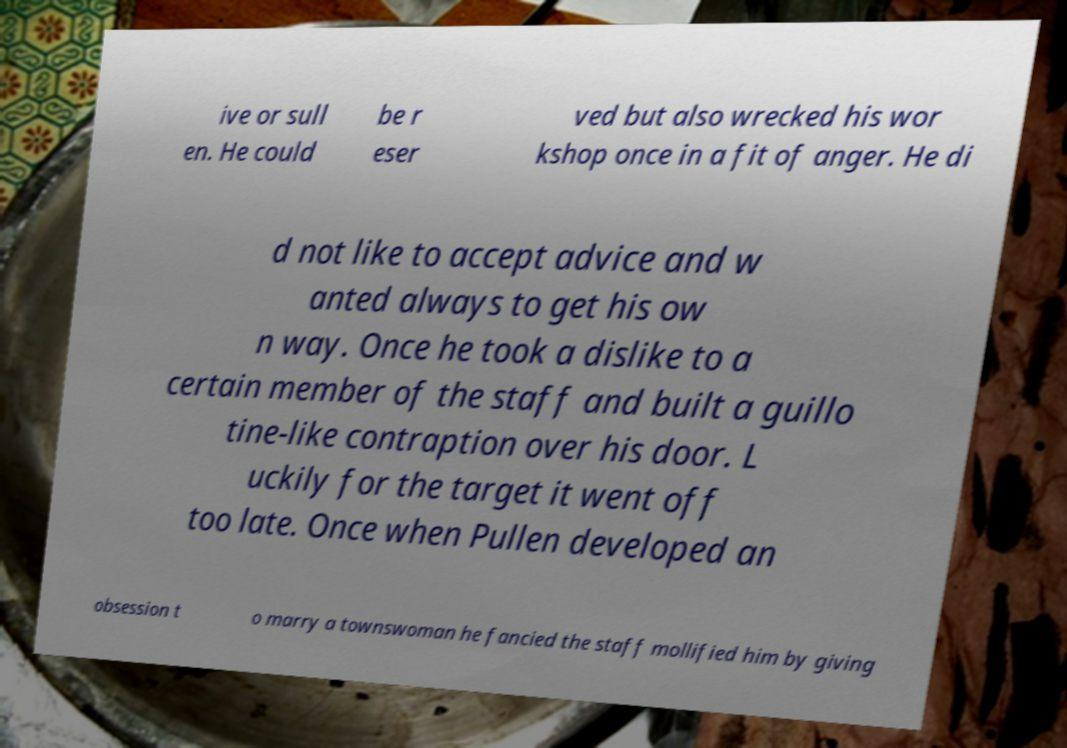I need the written content from this picture converted into text. Can you do that? ive or sull en. He could be r eser ved but also wrecked his wor kshop once in a fit of anger. He di d not like to accept advice and w anted always to get his ow n way. Once he took a dislike to a certain member of the staff and built a guillo tine-like contraption over his door. L uckily for the target it went off too late. Once when Pullen developed an obsession t o marry a townswoman he fancied the staff mollified him by giving 